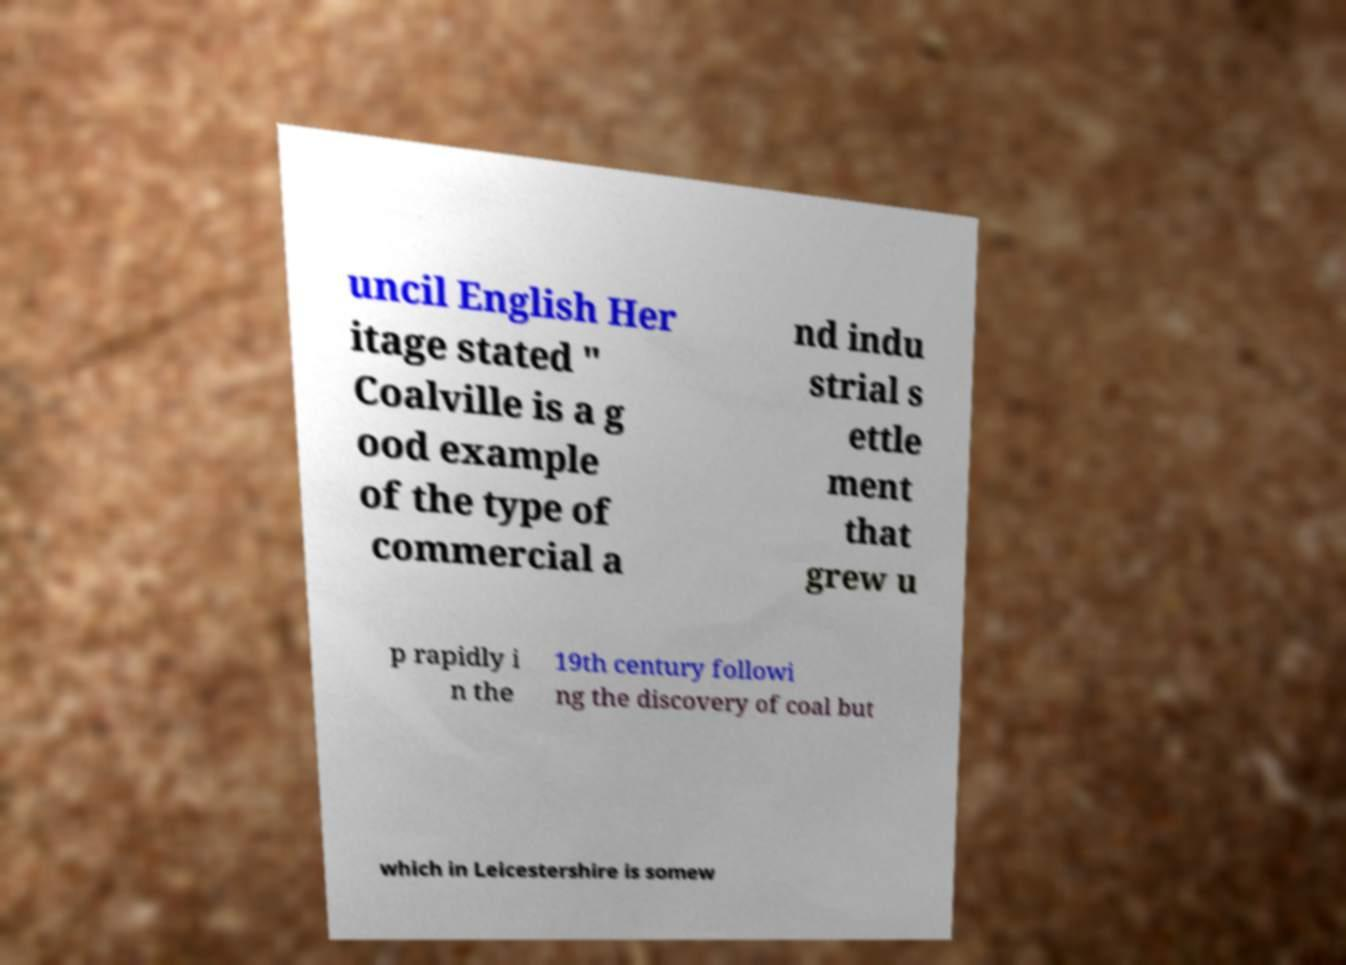Please identify and transcribe the text found in this image. uncil English Her itage stated " Coalville is a g ood example of the type of commercial a nd indu strial s ettle ment that grew u p rapidly i n the 19th century followi ng the discovery of coal but which in Leicestershire is somew 